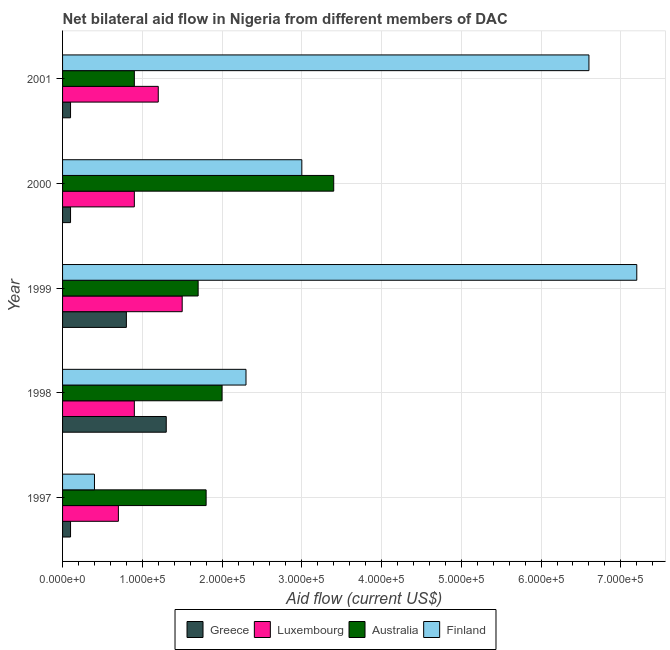How many groups of bars are there?
Offer a terse response. 5. Are the number of bars on each tick of the Y-axis equal?
Ensure brevity in your answer.  Yes. How many bars are there on the 4th tick from the top?
Your response must be concise. 4. What is the label of the 5th group of bars from the top?
Your answer should be very brief. 1997. In how many cases, is the number of bars for a given year not equal to the number of legend labels?
Your answer should be very brief. 0. What is the amount of aid given by australia in 1997?
Offer a very short reply. 1.80e+05. Across all years, what is the maximum amount of aid given by finland?
Keep it short and to the point. 7.20e+05. Across all years, what is the minimum amount of aid given by luxembourg?
Give a very brief answer. 7.00e+04. In which year was the amount of aid given by greece maximum?
Your answer should be very brief. 1998. In which year was the amount of aid given by greece minimum?
Ensure brevity in your answer.  1997. What is the total amount of aid given by australia in the graph?
Offer a terse response. 9.80e+05. What is the difference between the amount of aid given by australia in 2000 and that in 2001?
Keep it short and to the point. 2.50e+05. What is the difference between the amount of aid given by finland in 1998 and the amount of aid given by greece in 2001?
Provide a succinct answer. 2.20e+05. What is the average amount of aid given by australia per year?
Ensure brevity in your answer.  1.96e+05. In the year 1997, what is the difference between the amount of aid given by luxembourg and amount of aid given by finland?
Offer a very short reply. 3.00e+04. Is the amount of aid given by finland in 1998 less than that in 2001?
Your answer should be very brief. Yes. What is the difference between the highest and the second highest amount of aid given by greece?
Make the answer very short. 5.00e+04. What is the difference between the highest and the lowest amount of aid given by luxembourg?
Keep it short and to the point. 8.00e+04. In how many years, is the amount of aid given by greece greater than the average amount of aid given by greece taken over all years?
Your response must be concise. 2. Is it the case that in every year, the sum of the amount of aid given by australia and amount of aid given by luxembourg is greater than the sum of amount of aid given by greece and amount of aid given by finland?
Offer a very short reply. No. What does the 4th bar from the top in 2000 represents?
Offer a terse response. Greece. What does the 2nd bar from the bottom in 2000 represents?
Provide a succinct answer. Luxembourg. Is it the case that in every year, the sum of the amount of aid given by greece and amount of aid given by luxembourg is greater than the amount of aid given by australia?
Keep it short and to the point. No. How many bars are there?
Your answer should be very brief. 20. Are the values on the major ticks of X-axis written in scientific E-notation?
Provide a succinct answer. Yes. Does the graph contain any zero values?
Provide a succinct answer. No. How many legend labels are there?
Your answer should be very brief. 4. How are the legend labels stacked?
Your answer should be very brief. Horizontal. What is the title of the graph?
Your answer should be very brief. Net bilateral aid flow in Nigeria from different members of DAC. What is the Aid flow (current US$) in Greece in 1997?
Offer a terse response. 10000. What is the Aid flow (current US$) in Finland in 1997?
Make the answer very short. 4.00e+04. What is the Aid flow (current US$) of Greece in 1998?
Offer a terse response. 1.30e+05. What is the Aid flow (current US$) of Australia in 1998?
Make the answer very short. 2.00e+05. What is the Aid flow (current US$) in Finland in 1998?
Make the answer very short. 2.30e+05. What is the Aid flow (current US$) in Greece in 1999?
Your answer should be compact. 8.00e+04. What is the Aid flow (current US$) of Finland in 1999?
Your response must be concise. 7.20e+05. What is the Aid flow (current US$) in Greece in 2000?
Give a very brief answer. 10000. What is the Aid flow (current US$) of Finland in 2000?
Offer a very short reply. 3.00e+05. What is the Aid flow (current US$) in Greece in 2001?
Provide a succinct answer. 10000. What is the Aid flow (current US$) of Luxembourg in 2001?
Your answer should be compact. 1.20e+05. What is the Aid flow (current US$) of Finland in 2001?
Ensure brevity in your answer.  6.60e+05. Across all years, what is the maximum Aid flow (current US$) in Finland?
Make the answer very short. 7.20e+05. Across all years, what is the minimum Aid flow (current US$) of Australia?
Your answer should be compact. 9.00e+04. What is the total Aid flow (current US$) of Luxembourg in the graph?
Offer a terse response. 5.20e+05. What is the total Aid flow (current US$) in Australia in the graph?
Provide a short and direct response. 9.80e+05. What is the total Aid flow (current US$) of Finland in the graph?
Your answer should be compact. 1.95e+06. What is the difference between the Aid flow (current US$) of Greece in 1997 and that in 1998?
Provide a short and direct response. -1.20e+05. What is the difference between the Aid flow (current US$) of Luxembourg in 1997 and that in 1998?
Your answer should be very brief. -2.00e+04. What is the difference between the Aid flow (current US$) of Finland in 1997 and that in 1998?
Your answer should be compact. -1.90e+05. What is the difference between the Aid flow (current US$) of Luxembourg in 1997 and that in 1999?
Your response must be concise. -8.00e+04. What is the difference between the Aid flow (current US$) in Australia in 1997 and that in 1999?
Give a very brief answer. 10000. What is the difference between the Aid flow (current US$) in Finland in 1997 and that in 1999?
Provide a short and direct response. -6.80e+05. What is the difference between the Aid flow (current US$) of Finland in 1997 and that in 2000?
Keep it short and to the point. -2.60e+05. What is the difference between the Aid flow (current US$) of Greece in 1997 and that in 2001?
Make the answer very short. 0. What is the difference between the Aid flow (current US$) of Luxembourg in 1997 and that in 2001?
Give a very brief answer. -5.00e+04. What is the difference between the Aid flow (current US$) of Finland in 1997 and that in 2001?
Make the answer very short. -6.20e+05. What is the difference between the Aid flow (current US$) in Luxembourg in 1998 and that in 1999?
Your answer should be very brief. -6.00e+04. What is the difference between the Aid flow (current US$) of Australia in 1998 and that in 1999?
Provide a succinct answer. 3.00e+04. What is the difference between the Aid flow (current US$) of Finland in 1998 and that in 1999?
Provide a short and direct response. -4.90e+05. What is the difference between the Aid flow (current US$) in Finland in 1998 and that in 2000?
Offer a very short reply. -7.00e+04. What is the difference between the Aid flow (current US$) in Greece in 1998 and that in 2001?
Offer a very short reply. 1.20e+05. What is the difference between the Aid flow (current US$) of Luxembourg in 1998 and that in 2001?
Offer a terse response. -3.00e+04. What is the difference between the Aid flow (current US$) of Australia in 1998 and that in 2001?
Provide a succinct answer. 1.10e+05. What is the difference between the Aid flow (current US$) in Finland in 1998 and that in 2001?
Keep it short and to the point. -4.30e+05. What is the difference between the Aid flow (current US$) in Luxembourg in 1999 and that in 2001?
Offer a very short reply. 3.00e+04. What is the difference between the Aid flow (current US$) in Finland in 1999 and that in 2001?
Your response must be concise. 6.00e+04. What is the difference between the Aid flow (current US$) in Greece in 2000 and that in 2001?
Make the answer very short. 0. What is the difference between the Aid flow (current US$) of Luxembourg in 2000 and that in 2001?
Provide a succinct answer. -3.00e+04. What is the difference between the Aid flow (current US$) in Finland in 2000 and that in 2001?
Offer a terse response. -3.60e+05. What is the difference between the Aid flow (current US$) in Greece in 1997 and the Aid flow (current US$) in Australia in 1998?
Offer a terse response. -1.90e+05. What is the difference between the Aid flow (current US$) in Luxembourg in 1997 and the Aid flow (current US$) in Australia in 1998?
Offer a terse response. -1.30e+05. What is the difference between the Aid flow (current US$) in Luxembourg in 1997 and the Aid flow (current US$) in Finland in 1998?
Your answer should be very brief. -1.60e+05. What is the difference between the Aid flow (current US$) in Australia in 1997 and the Aid flow (current US$) in Finland in 1998?
Keep it short and to the point. -5.00e+04. What is the difference between the Aid flow (current US$) of Greece in 1997 and the Aid flow (current US$) of Australia in 1999?
Ensure brevity in your answer.  -1.60e+05. What is the difference between the Aid flow (current US$) in Greece in 1997 and the Aid flow (current US$) in Finland in 1999?
Offer a very short reply. -7.10e+05. What is the difference between the Aid flow (current US$) of Luxembourg in 1997 and the Aid flow (current US$) of Finland in 1999?
Your answer should be very brief. -6.50e+05. What is the difference between the Aid flow (current US$) in Australia in 1997 and the Aid flow (current US$) in Finland in 1999?
Keep it short and to the point. -5.40e+05. What is the difference between the Aid flow (current US$) in Greece in 1997 and the Aid flow (current US$) in Australia in 2000?
Offer a very short reply. -3.30e+05. What is the difference between the Aid flow (current US$) of Greece in 1997 and the Aid flow (current US$) of Finland in 2000?
Ensure brevity in your answer.  -2.90e+05. What is the difference between the Aid flow (current US$) of Luxembourg in 1997 and the Aid flow (current US$) of Australia in 2000?
Offer a very short reply. -2.70e+05. What is the difference between the Aid flow (current US$) of Greece in 1997 and the Aid flow (current US$) of Luxembourg in 2001?
Offer a terse response. -1.10e+05. What is the difference between the Aid flow (current US$) in Greece in 1997 and the Aid flow (current US$) in Australia in 2001?
Keep it short and to the point. -8.00e+04. What is the difference between the Aid flow (current US$) in Greece in 1997 and the Aid flow (current US$) in Finland in 2001?
Provide a succinct answer. -6.50e+05. What is the difference between the Aid flow (current US$) in Luxembourg in 1997 and the Aid flow (current US$) in Finland in 2001?
Your answer should be very brief. -5.90e+05. What is the difference between the Aid flow (current US$) of Australia in 1997 and the Aid flow (current US$) of Finland in 2001?
Provide a short and direct response. -4.80e+05. What is the difference between the Aid flow (current US$) of Greece in 1998 and the Aid flow (current US$) of Luxembourg in 1999?
Provide a short and direct response. -2.00e+04. What is the difference between the Aid flow (current US$) of Greece in 1998 and the Aid flow (current US$) of Australia in 1999?
Offer a terse response. -4.00e+04. What is the difference between the Aid flow (current US$) of Greece in 1998 and the Aid flow (current US$) of Finland in 1999?
Provide a succinct answer. -5.90e+05. What is the difference between the Aid flow (current US$) of Luxembourg in 1998 and the Aid flow (current US$) of Finland in 1999?
Make the answer very short. -6.30e+05. What is the difference between the Aid flow (current US$) in Australia in 1998 and the Aid flow (current US$) in Finland in 1999?
Offer a very short reply. -5.20e+05. What is the difference between the Aid flow (current US$) in Greece in 1998 and the Aid flow (current US$) in Luxembourg in 2000?
Offer a terse response. 4.00e+04. What is the difference between the Aid flow (current US$) of Greece in 1998 and the Aid flow (current US$) of Australia in 2000?
Make the answer very short. -2.10e+05. What is the difference between the Aid flow (current US$) of Greece in 1998 and the Aid flow (current US$) of Finland in 2000?
Keep it short and to the point. -1.70e+05. What is the difference between the Aid flow (current US$) in Luxembourg in 1998 and the Aid flow (current US$) in Australia in 2000?
Make the answer very short. -2.50e+05. What is the difference between the Aid flow (current US$) of Luxembourg in 1998 and the Aid flow (current US$) of Finland in 2000?
Offer a terse response. -2.10e+05. What is the difference between the Aid flow (current US$) of Greece in 1998 and the Aid flow (current US$) of Finland in 2001?
Offer a terse response. -5.30e+05. What is the difference between the Aid flow (current US$) in Luxembourg in 1998 and the Aid flow (current US$) in Australia in 2001?
Give a very brief answer. 0. What is the difference between the Aid flow (current US$) of Luxembourg in 1998 and the Aid flow (current US$) of Finland in 2001?
Provide a succinct answer. -5.70e+05. What is the difference between the Aid flow (current US$) of Australia in 1998 and the Aid flow (current US$) of Finland in 2001?
Your answer should be compact. -4.60e+05. What is the difference between the Aid flow (current US$) in Greece in 1999 and the Aid flow (current US$) in Luxembourg in 2001?
Your answer should be compact. -4.00e+04. What is the difference between the Aid flow (current US$) of Greece in 1999 and the Aid flow (current US$) of Australia in 2001?
Keep it short and to the point. -10000. What is the difference between the Aid flow (current US$) in Greece in 1999 and the Aid flow (current US$) in Finland in 2001?
Provide a short and direct response. -5.80e+05. What is the difference between the Aid flow (current US$) of Luxembourg in 1999 and the Aid flow (current US$) of Finland in 2001?
Your answer should be very brief. -5.10e+05. What is the difference between the Aid flow (current US$) of Australia in 1999 and the Aid flow (current US$) of Finland in 2001?
Offer a terse response. -4.90e+05. What is the difference between the Aid flow (current US$) in Greece in 2000 and the Aid flow (current US$) in Luxembourg in 2001?
Make the answer very short. -1.10e+05. What is the difference between the Aid flow (current US$) in Greece in 2000 and the Aid flow (current US$) in Australia in 2001?
Make the answer very short. -8.00e+04. What is the difference between the Aid flow (current US$) of Greece in 2000 and the Aid flow (current US$) of Finland in 2001?
Give a very brief answer. -6.50e+05. What is the difference between the Aid flow (current US$) of Luxembourg in 2000 and the Aid flow (current US$) of Finland in 2001?
Provide a succinct answer. -5.70e+05. What is the difference between the Aid flow (current US$) in Australia in 2000 and the Aid flow (current US$) in Finland in 2001?
Your response must be concise. -3.20e+05. What is the average Aid flow (current US$) of Greece per year?
Offer a very short reply. 4.80e+04. What is the average Aid flow (current US$) of Luxembourg per year?
Your answer should be compact. 1.04e+05. What is the average Aid flow (current US$) in Australia per year?
Offer a terse response. 1.96e+05. In the year 1997, what is the difference between the Aid flow (current US$) of Greece and Aid flow (current US$) of Luxembourg?
Keep it short and to the point. -6.00e+04. In the year 1997, what is the difference between the Aid flow (current US$) in Greece and Aid flow (current US$) in Australia?
Provide a succinct answer. -1.70e+05. In the year 1997, what is the difference between the Aid flow (current US$) in Luxembourg and Aid flow (current US$) in Australia?
Give a very brief answer. -1.10e+05. In the year 1997, what is the difference between the Aid flow (current US$) in Luxembourg and Aid flow (current US$) in Finland?
Offer a very short reply. 3.00e+04. In the year 1998, what is the difference between the Aid flow (current US$) of Greece and Aid flow (current US$) of Luxembourg?
Make the answer very short. 4.00e+04. In the year 1998, what is the difference between the Aid flow (current US$) of Greece and Aid flow (current US$) of Australia?
Ensure brevity in your answer.  -7.00e+04. In the year 1998, what is the difference between the Aid flow (current US$) of Greece and Aid flow (current US$) of Finland?
Keep it short and to the point. -1.00e+05. In the year 1998, what is the difference between the Aid flow (current US$) of Australia and Aid flow (current US$) of Finland?
Your answer should be compact. -3.00e+04. In the year 1999, what is the difference between the Aid flow (current US$) of Greece and Aid flow (current US$) of Luxembourg?
Provide a succinct answer. -7.00e+04. In the year 1999, what is the difference between the Aid flow (current US$) in Greece and Aid flow (current US$) in Finland?
Give a very brief answer. -6.40e+05. In the year 1999, what is the difference between the Aid flow (current US$) of Luxembourg and Aid flow (current US$) of Finland?
Your answer should be very brief. -5.70e+05. In the year 1999, what is the difference between the Aid flow (current US$) in Australia and Aid flow (current US$) in Finland?
Keep it short and to the point. -5.50e+05. In the year 2000, what is the difference between the Aid flow (current US$) of Greece and Aid flow (current US$) of Australia?
Your answer should be compact. -3.30e+05. In the year 2000, what is the difference between the Aid flow (current US$) in Greece and Aid flow (current US$) in Finland?
Your response must be concise. -2.90e+05. In the year 2001, what is the difference between the Aid flow (current US$) of Greece and Aid flow (current US$) of Luxembourg?
Your answer should be compact. -1.10e+05. In the year 2001, what is the difference between the Aid flow (current US$) of Greece and Aid flow (current US$) of Australia?
Provide a short and direct response. -8.00e+04. In the year 2001, what is the difference between the Aid flow (current US$) in Greece and Aid flow (current US$) in Finland?
Keep it short and to the point. -6.50e+05. In the year 2001, what is the difference between the Aid flow (current US$) of Luxembourg and Aid flow (current US$) of Australia?
Give a very brief answer. 3.00e+04. In the year 2001, what is the difference between the Aid flow (current US$) in Luxembourg and Aid flow (current US$) in Finland?
Offer a very short reply. -5.40e+05. In the year 2001, what is the difference between the Aid flow (current US$) in Australia and Aid flow (current US$) in Finland?
Your answer should be very brief. -5.70e+05. What is the ratio of the Aid flow (current US$) in Greece in 1997 to that in 1998?
Make the answer very short. 0.08. What is the ratio of the Aid flow (current US$) of Australia in 1997 to that in 1998?
Offer a very short reply. 0.9. What is the ratio of the Aid flow (current US$) in Finland in 1997 to that in 1998?
Ensure brevity in your answer.  0.17. What is the ratio of the Aid flow (current US$) of Greece in 1997 to that in 1999?
Make the answer very short. 0.12. What is the ratio of the Aid flow (current US$) in Luxembourg in 1997 to that in 1999?
Give a very brief answer. 0.47. What is the ratio of the Aid flow (current US$) of Australia in 1997 to that in 1999?
Provide a succinct answer. 1.06. What is the ratio of the Aid flow (current US$) in Finland in 1997 to that in 1999?
Ensure brevity in your answer.  0.06. What is the ratio of the Aid flow (current US$) in Greece in 1997 to that in 2000?
Make the answer very short. 1. What is the ratio of the Aid flow (current US$) in Australia in 1997 to that in 2000?
Ensure brevity in your answer.  0.53. What is the ratio of the Aid flow (current US$) of Finland in 1997 to that in 2000?
Make the answer very short. 0.13. What is the ratio of the Aid flow (current US$) in Luxembourg in 1997 to that in 2001?
Provide a succinct answer. 0.58. What is the ratio of the Aid flow (current US$) of Finland in 1997 to that in 2001?
Provide a succinct answer. 0.06. What is the ratio of the Aid flow (current US$) in Greece in 1998 to that in 1999?
Give a very brief answer. 1.62. What is the ratio of the Aid flow (current US$) in Australia in 1998 to that in 1999?
Provide a short and direct response. 1.18. What is the ratio of the Aid flow (current US$) of Finland in 1998 to that in 1999?
Make the answer very short. 0.32. What is the ratio of the Aid flow (current US$) of Greece in 1998 to that in 2000?
Give a very brief answer. 13. What is the ratio of the Aid flow (current US$) in Luxembourg in 1998 to that in 2000?
Offer a terse response. 1. What is the ratio of the Aid flow (current US$) of Australia in 1998 to that in 2000?
Your response must be concise. 0.59. What is the ratio of the Aid flow (current US$) of Finland in 1998 to that in 2000?
Offer a terse response. 0.77. What is the ratio of the Aid flow (current US$) of Greece in 1998 to that in 2001?
Provide a succinct answer. 13. What is the ratio of the Aid flow (current US$) of Australia in 1998 to that in 2001?
Offer a terse response. 2.22. What is the ratio of the Aid flow (current US$) of Finland in 1998 to that in 2001?
Ensure brevity in your answer.  0.35. What is the ratio of the Aid flow (current US$) of Australia in 1999 to that in 2000?
Your answer should be very brief. 0.5. What is the ratio of the Aid flow (current US$) of Finland in 1999 to that in 2000?
Keep it short and to the point. 2.4. What is the ratio of the Aid flow (current US$) in Australia in 1999 to that in 2001?
Your answer should be compact. 1.89. What is the ratio of the Aid flow (current US$) of Finland in 1999 to that in 2001?
Ensure brevity in your answer.  1.09. What is the ratio of the Aid flow (current US$) of Greece in 2000 to that in 2001?
Your answer should be compact. 1. What is the ratio of the Aid flow (current US$) in Luxembourg in 2000 to that in 2001?
Your answer should be compact. 0.75. What is the ratio of the Aid flow (current US$) in Australia in 2000 to that in 2001?
Make the answer very short. 3.78. What is the ratio of the Aid flow (current US$) in Finland in 2000 to that in 2001?
Your answer should be compact. 0.45. What is the difference between the highest and the second highest Aid flow (current US$) in Luxembourg?
Make the answer very short. 3.00e+04. What is the difference between the highest and the second highest Aid flow (current US$) in Australia?
Your response must be concise. 1.40e+05. What is the difference between the highest and the second highest Aid flow (current US$) in Finland?
Your response must be concise. 6.00e+04. What is the difference between the highest and the lowest Aid flow (current US$) in Greece?
Provide a succinct answer. 1.20e+05. What is the difference between the highest and the lowest Aid flow (current US$) in Australia?
Your response must be concise. 2.50e+05. What is the difference between the highest and the lowest Aid flow (current US$) in Finland?
Give a very brief answer. 6.80e+05. 